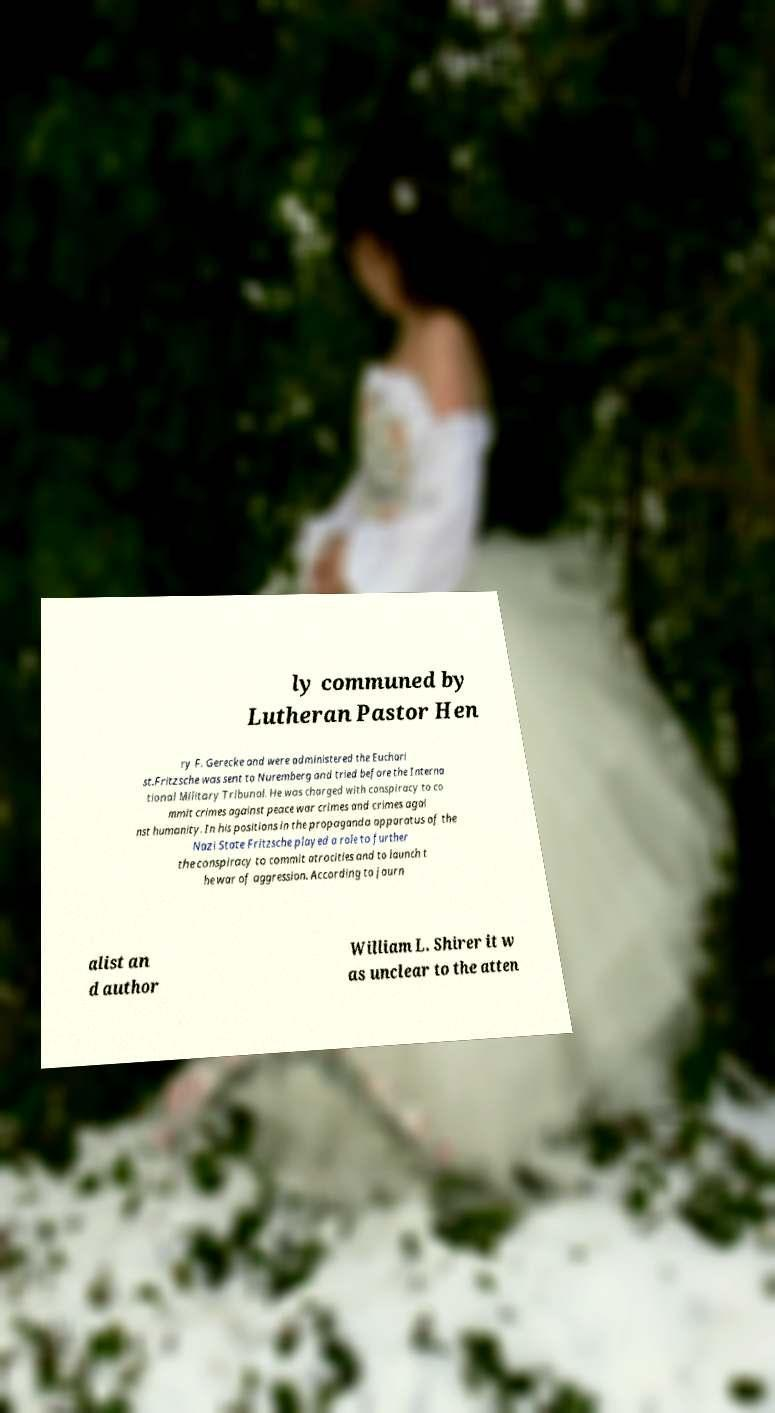Please identify and transcribe the text found in this image. ly communed by Lutheran Pastor Hen ry F. Gerecke and were administered the Euchari st.Fritzsche was sent to Nuremberg and tried before the Interna tional Military Tribunal. He was charged with conspiracy to co mmit crimes against peace war crimes and crimes agai nst humanity. In his positions in the propaganda apparatus of the Nazi State Fritzsche played a role to further the conspiracy to commit atrocities and to launch t he war of aggression. According to journ alist an d author William L. Shirer it w as unclear to the atten 